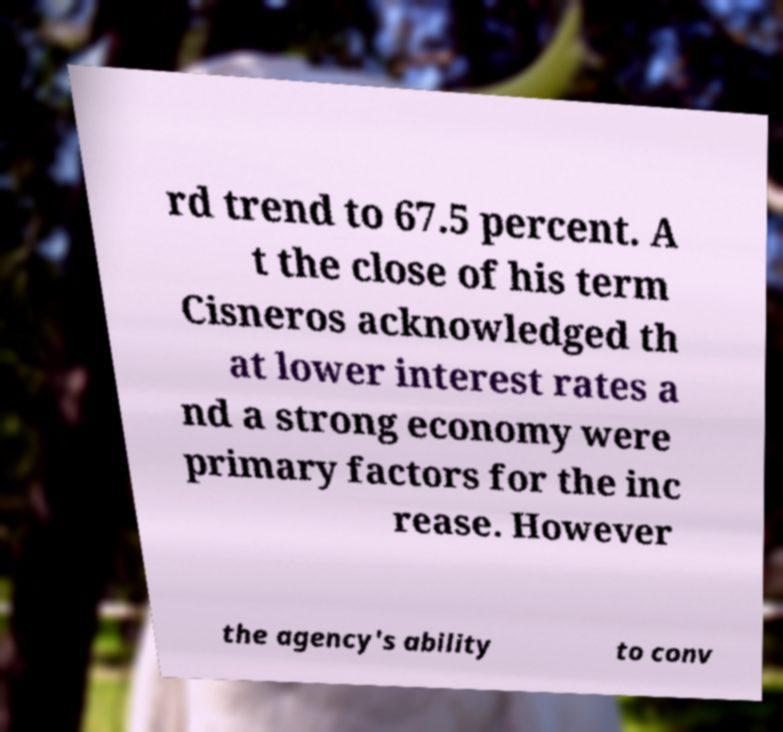I need the written content from this picture converted into text. Can you do that? rd trend to 67.5 percent. A t the close of his term Cisneros acknowledged th at lower interest rates a nd a strong economy were primary factors for the inc rease. However the agency's ability to conv 